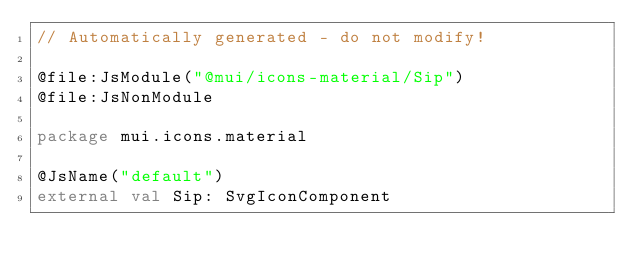<code> <loc_0><loc_0><loc_500><loc_500><_Kotlin_>// Automatically generated - do not modify!

@file:JsModule("@mui/icons-material/Sip")
@file:JsNonModule

package mui.icons.material

@JsName("default")
external val Sip: SvgIconComponent
</code> 